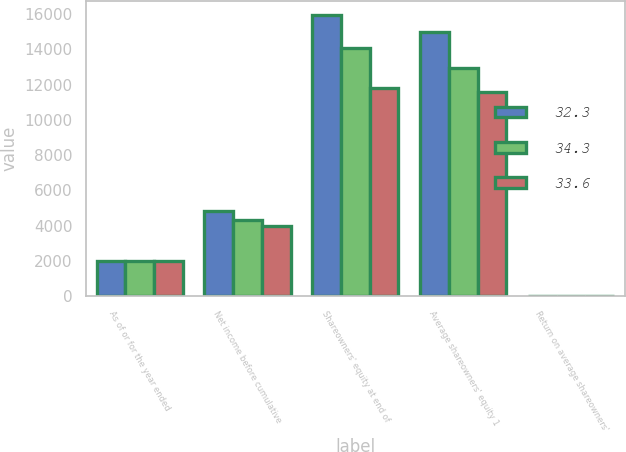Convert chart to OTSL. <chart><loc_0><loc_0><loc_500><loc_500><stacked_bar_chart><ecel><fcel>As of or for the year ended<fcel>Net income before cumulative<fcel>Shareowners' equity at end of<fcel>Average shareowners' equity 1<fcel>Return on average shareowners'<nl><fcel>32.3<fcel>2004<fcel>4847<fcel>15935<fcel>15013<fcel>32.3<nl><fcel>34.3<fcel>2003<fcel>4347<fcel>14090<fcel>12945<fcel>33.6<nl><fcel>33.6<fcel>2002<fcel>3976<fcel>11800<fcel>11583<fcel>34.3<nl></chart> 